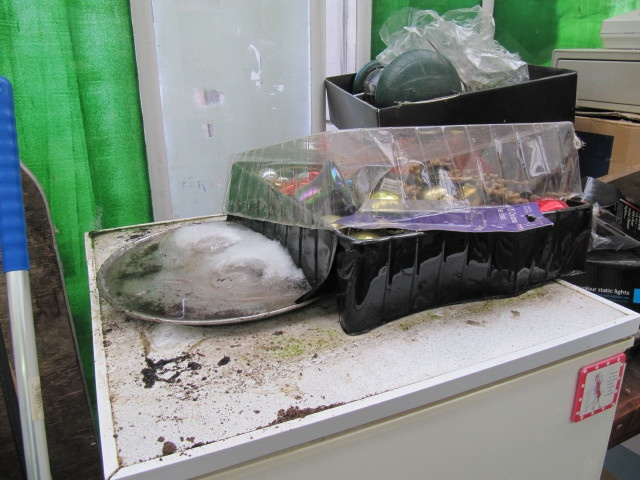Describe the objects in this image and their specific colors. I can see a refrigerator in green, darkgray, lightgray, and gray tones in this image. 